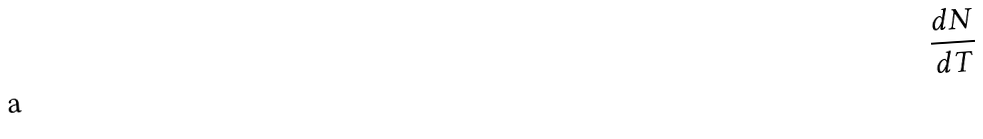<formula> <loc_0><loc_0><loc_500><loc_500>\frac { d N } { d T }</formula> 